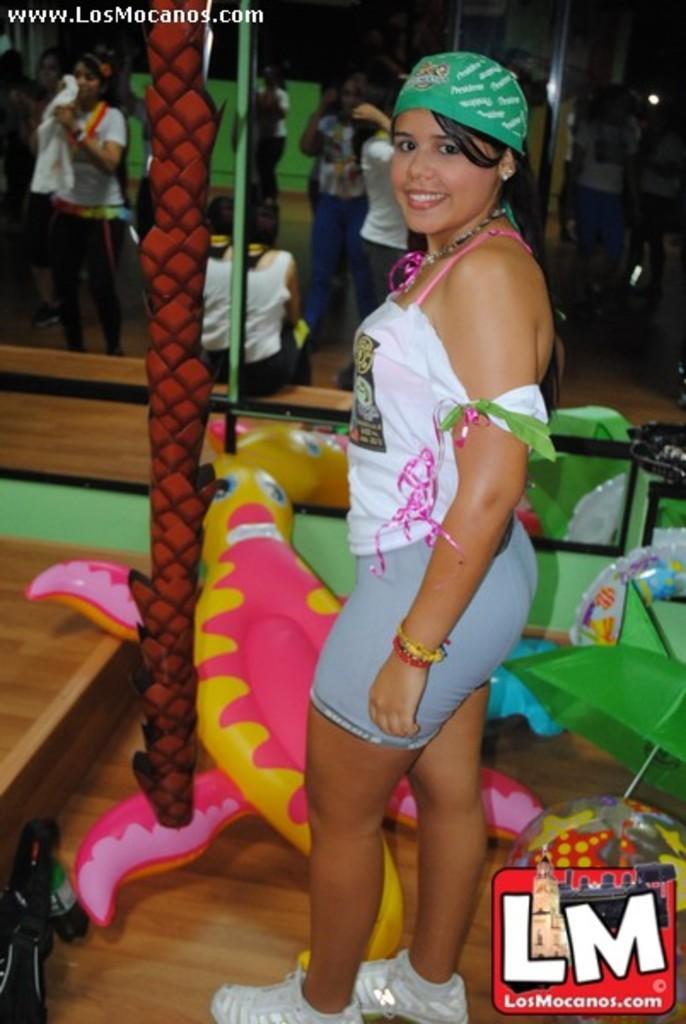In one or two sentences, can you explain what this image depicts? In this image I can see a woman standing and posing for the picture. I can see a balloon toy in front of her. I can see a mirror at the top of the image. In the top left and bottom right corners I can see some text. 